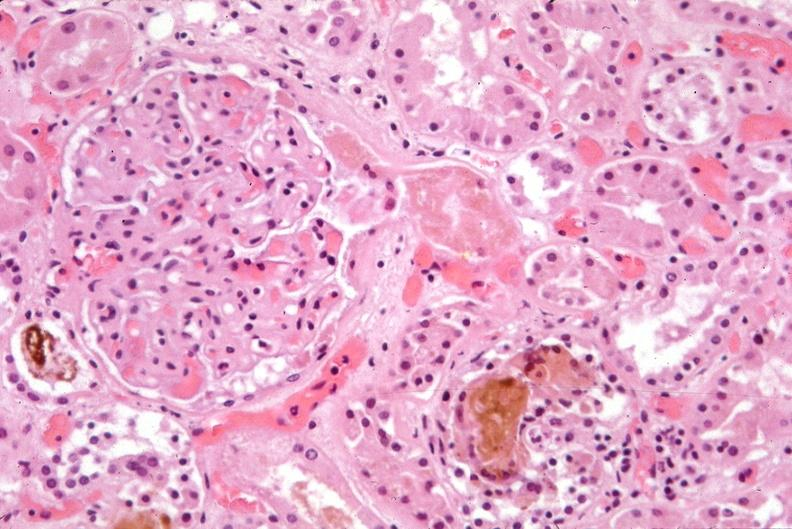what does this image show?
Answer the question using a single word or phrase. Kidney 